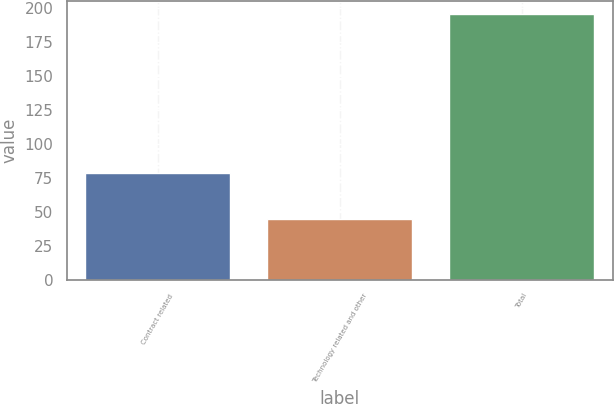<chart> <loc_0><loc_0><loc_500><loc_500><bar_chart><fcel>Contract related<fcel>Technology related and other<fcel>Total<nl><fcel>79<fcel>45<fcel>196<nl></chart> 